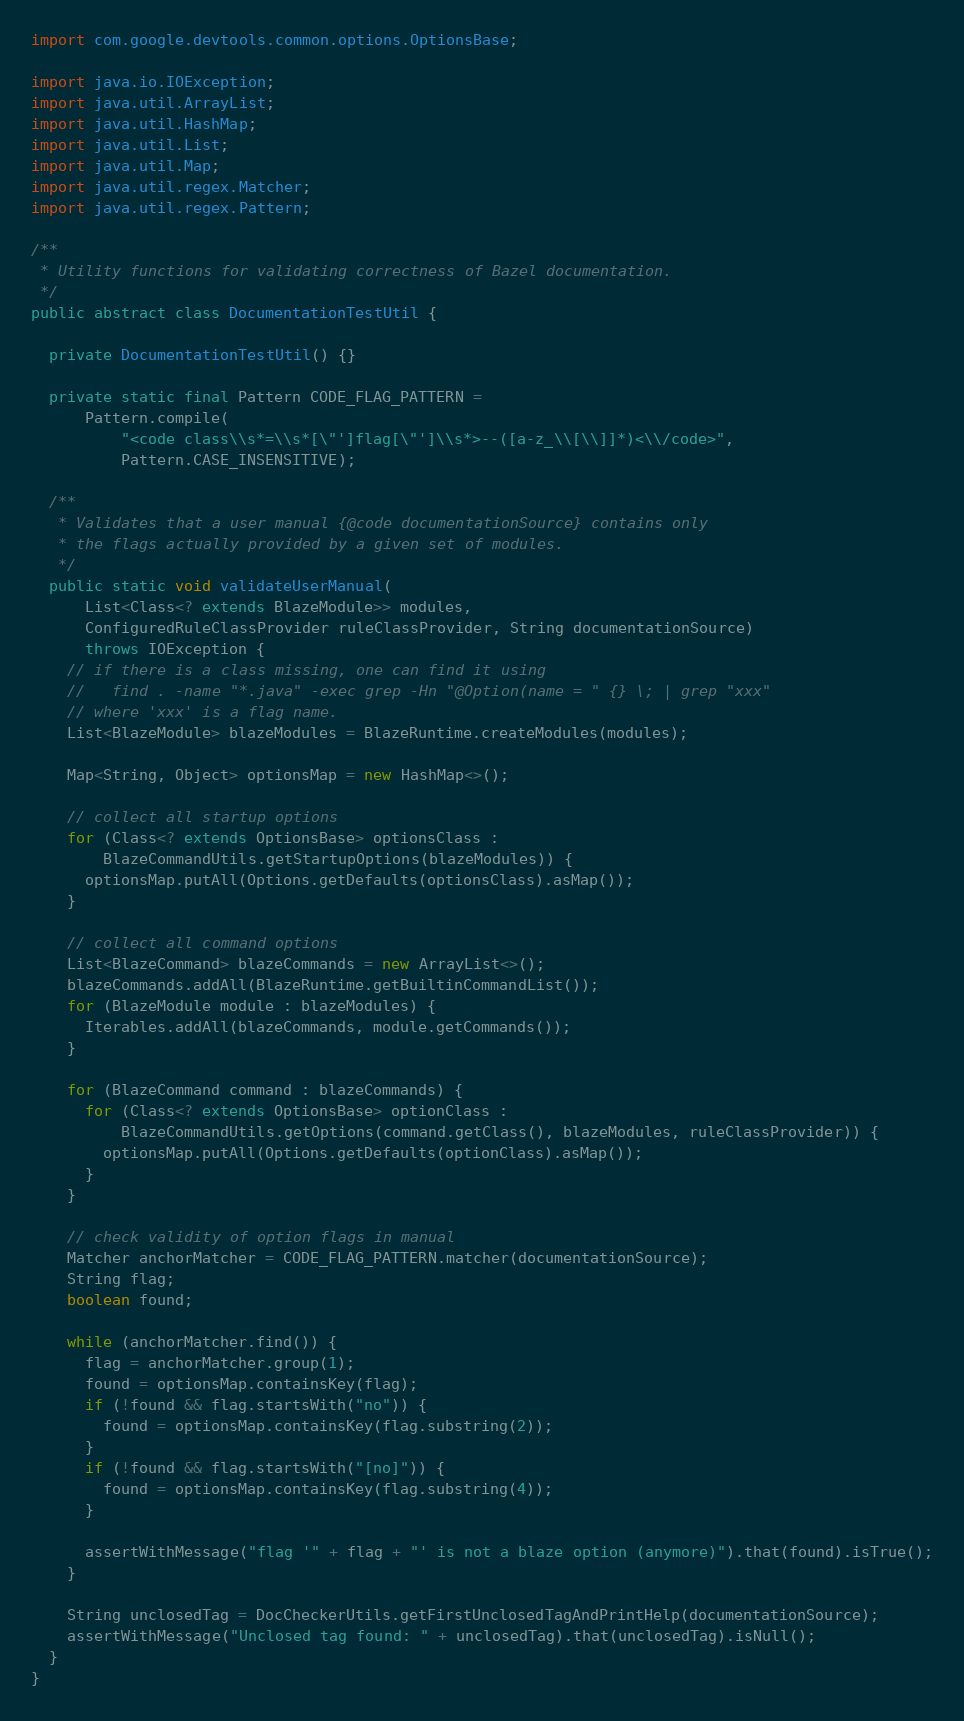Convert code to text. <code><loc_0><loc_0><loc_500><loc_500><_Java_>import com.google.devtools.common.options.OptionsBase;

import java.io.IOException;
import java.util.ArrayList;
import java.util.HashMap;
import java.util.List;
import java.util.Map;
import java.util.regex.Matcher;
import java.util.regex.Pattern;

/**
 * Utility functions for validating correctness of Bazel documentation.
 */
public abstract class DocumentationTestUtil {

  private DocumentationTestUtil() {}

  private static final Pattern CODE_FLAG_PATTERN =
      Pattern.compile(
          "<code class\\s*=\\s*[\"']flag[\"']\\s*>--([a-z_\\[\\]]*)<\\/code>",
          Pattern.CASE_INSENSITIVE);

  /**
   * Validates that a user manual {@code documentationSource} contains only
   * the flags actually provided by a given set of modules.
   */
  public static void validateUserManual(
      List<Class<? extends BlazeModule>> modules,
      ConfiguredRuleClassProvider ruleClassProvider, String documentationSource)
      throws IOException {
    // if there is a class missing, one can find it using
    //   find . -name "*.java" -exec grep -Hn "@Option(name = " {} \; | grep "xxx"
    // where 'xxx' is a flag name.
    List<BlazeModule> blazeModules = BlazeRuntime.createModules(modules);

    Map<String, Object> optionsMap = new HashMap<>();

    // collect all startup options
    for (Class<? extends OptionsBase> optionsClass :
        BlazeCommandUtils.getStartupOptions(blazeModules)) {
      optionsMap.putAll(Options.getDefaults(optionsClass).asMap());
    }

    // collect all command options
    List<BlazeCommand> blazeCommands = new ArrayList<>();
    blazeCommands.addAll(BlazeRuntime.getBuiltinCommandList());
    for (BlazeModule module : blazeModules) {
      Iterables.addAll(blazeCommands, module.getCommands());
    }

    for (BlazeCommand command : blazeCommands) {
      for (Class<? extends OptionsBase> optionClass :
          BlazeCommandUtils.getOptions(command.getClass(), blazeModules, ruleClassProvider)) {
        optionsMap.putAll(Options.getDefaults(optionClass).asMap());
      }
    }

    // check validity of option flags in manual
    Matcher anchorMatcher = CODE_FLAG_PATTERN.matcher(documentationSource);
    String flag;
    boolean found;

    while (anchorMatcher.find()) {
      flag = anchorMatcher.group(1);
      found = optionsMap.containsKey(flag);
      if (!found && flag.startsWith("no")) {
        found = optionsMap.containsKey(flag.substring(2));
      }
      if (!found && flag.startsWith("[no]")) {
        found = optionsMap.containsKey(flag.substring(4));
      }

      assertWithMessage("flag '" + flag + "' is not a blaze option (anymore)").that(found).isTrue();
    }

    String unclosedTag = DocCheckerUtils.getFirstUnclosedTagAndPrintHelp(documentationSource);
    assertWithMessage("Unclosed tag found: " + unclosedTag).that(unclosedTag).isNull();
  }
}
</code> 